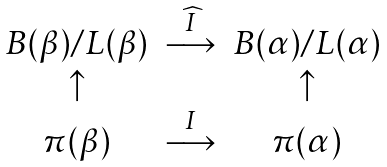<formula> <loc_0><loc_0><loc_500><loc_500>\begin{matrix} B ( \beta ) / L ( \beta ) & \overset { \widehat { I } } { \longrightarrow } & B ( \alpha ) / L ( \alpha ) \\ \uparrow & & \uparrow \\ \pi ( \beta ) & \overset { I } { \longrightarrow } & \pi ( \alpha ) \end{matrix}</formula> 